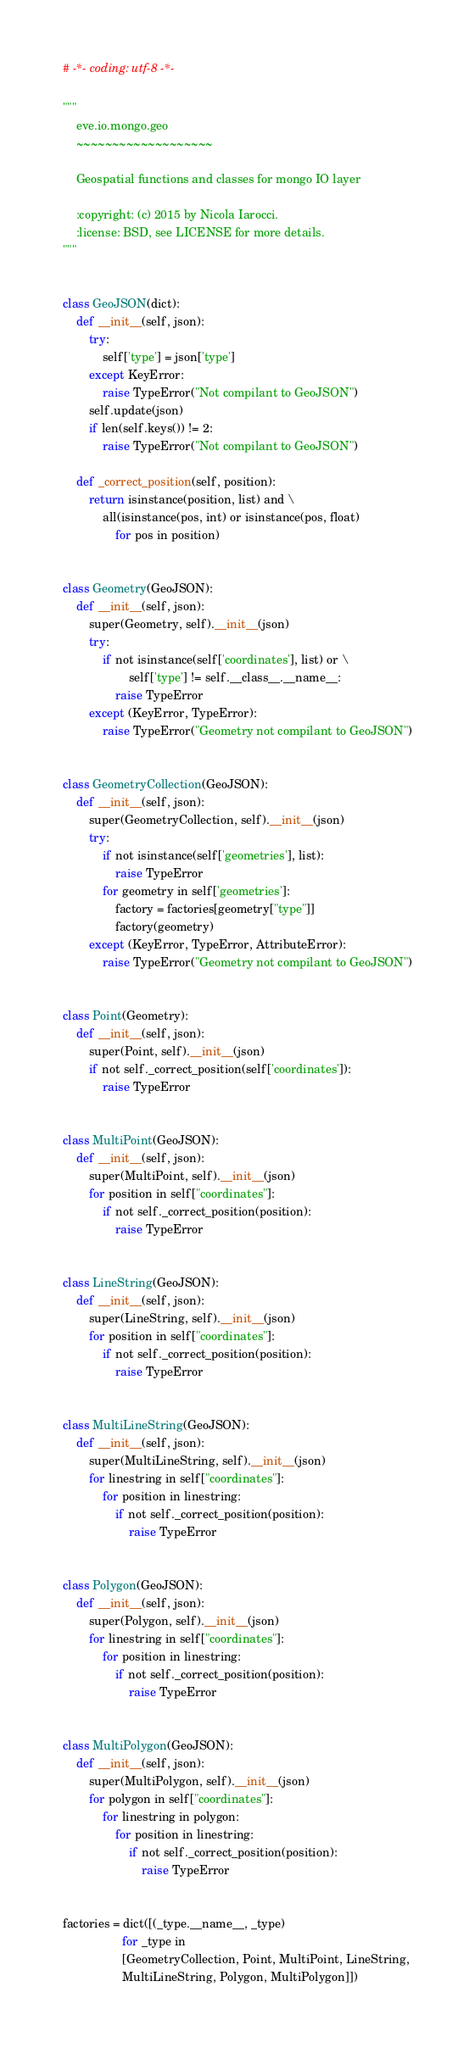Convert code to text. <code><loc_0><loc_0><loc_500><loc_500><_Python_># -*- coding: utf-8 -*-

"""
    eve.io.mongo.geo
    ~~~~~~~~~~~~~~~~~~~

    Geospatial functions and classes for mongo IO layer

    :copyright: (c) 2015 by Nicola Iarocci.
    :license: BSD, see LICENSE for more details.
"""


class GeoJSON(dict):
    def __init__(self, json):
        try:
            self['type'] = json['type']
        except KeyError:
            raise TypeError("Not compilant to GeoJSON")
        self.update(json)
        if len(self.keys()) != 2:
            raise TypeError("Not compilant to GeoJSON")

    def _correct_position(self, position):
        return isinstance(position, list) and \
            all(isinstance(pos, int) or isinstance(pos, float)
                for pos in position)


class Geometry(GeoJSON):
    def __init__(self, json):
        super(Geometry, self).__init__(json)
        try:
            if not isinstance(self['coordinates'], list) or \
                    self['type'] != self.__class__.__name__:
                raise TypeError
        except (KeyError, TypeError):
            raise TypeError("Geometry not compilant to GeoJSON")


class GeometryCollection(GeoJSON):
    def __init__(self, json):
        super(GeometryCollection, self).__init__(json)
        try:
            if not isinstance(self['geometries'], list):
                raise TypeError
            for geometry in self['geometries']:
                factory = factories[geometry["type"]]
                factory(geometry)
        except (KeyError, TypeError, AttributeError):
            raise TypeError("Geometry not compilant to GeoJSON")


class Point(Geometry):
    def __init__(self, json):
        super(Point, self).__init__(json)
        if not self._correct_position(self['coordinates']):
            raise TypeError


class MultiPoint(GeoJSON):
    def __init__(self, json):
        super(MultiPoint, self).__init__(json)
        for position in self["coordinates"]:
            if not self._correct_position(position):
                raise TypeError


class LineString(GeoJSON):
    def __init__(self, json):
        super(LineString, self).__init__(json)
        for position in self["coordinates"]:
            if not self._correct_position(position):
                raise TypeError


class MultiLineString(GeoJSON):
    def __init__(self, json):
        super(MultiLineString, self).__init__(json)
        for linestring in self["coordinates"]:
            for position in linestring:
                if not self._correct_position(position):
                    raise TypeError


class Polygon(GeoJSON):
    def __init__(self, json):
        super(Polygon, self).__init__(json)
        for linestring in self["coordinates"]:
            for position in linestring:
                if not self._correct_position(position):
                    raise TypeError


class MultiPolygon(GeoJSON):
    def __init__(self, json):
        super(MultiPolygon, self).__init__(json)
        for polygon in self["coordinates"]:
            for linestring in polygon:
                for position in linestring:
                    if not self._correct_position(position):
                        raise TypeError


factories = dict([(_type.__name__, _type)
                  for _type in
                  [GeometryCollection, Point, MultiPoint, LineString,
                  MultiLineString, Polygon, MultiPolygon]])
</code> 